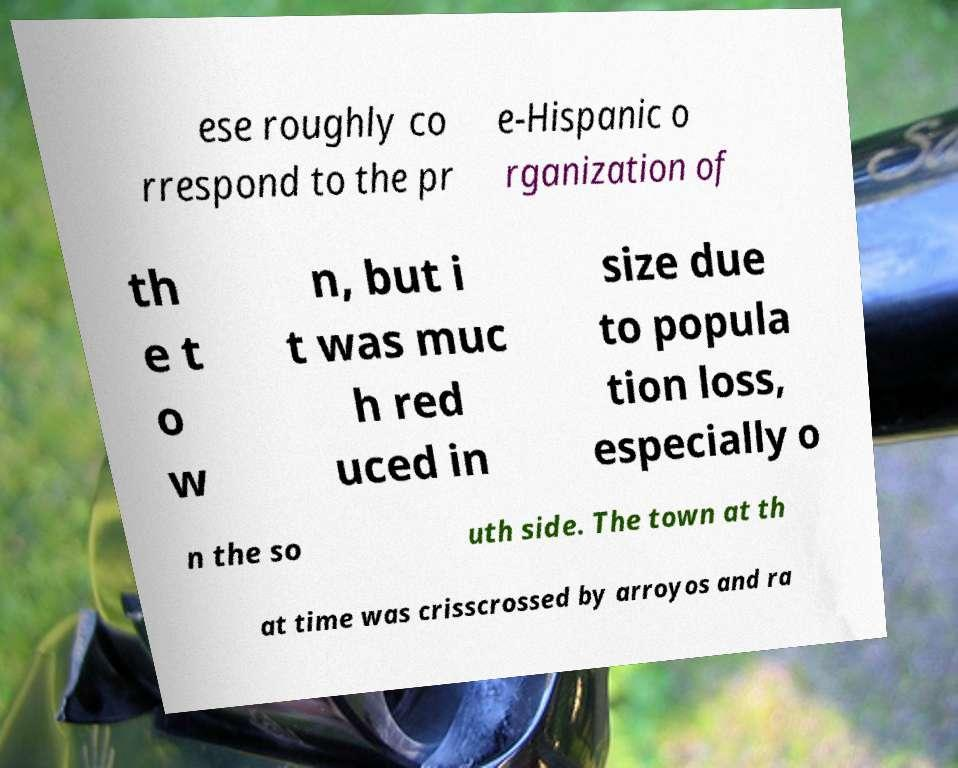For documentation purposes, I need the text within this image transcribed. Could you provide that? ese roughly co rrespond to the pr e-Hispanic o rganization of th e t o w n, but i t was muc h red uced in size due to popula tion loss, especially o n the so uth side. The town at th at time was crisscrossed by arroyos and ra 